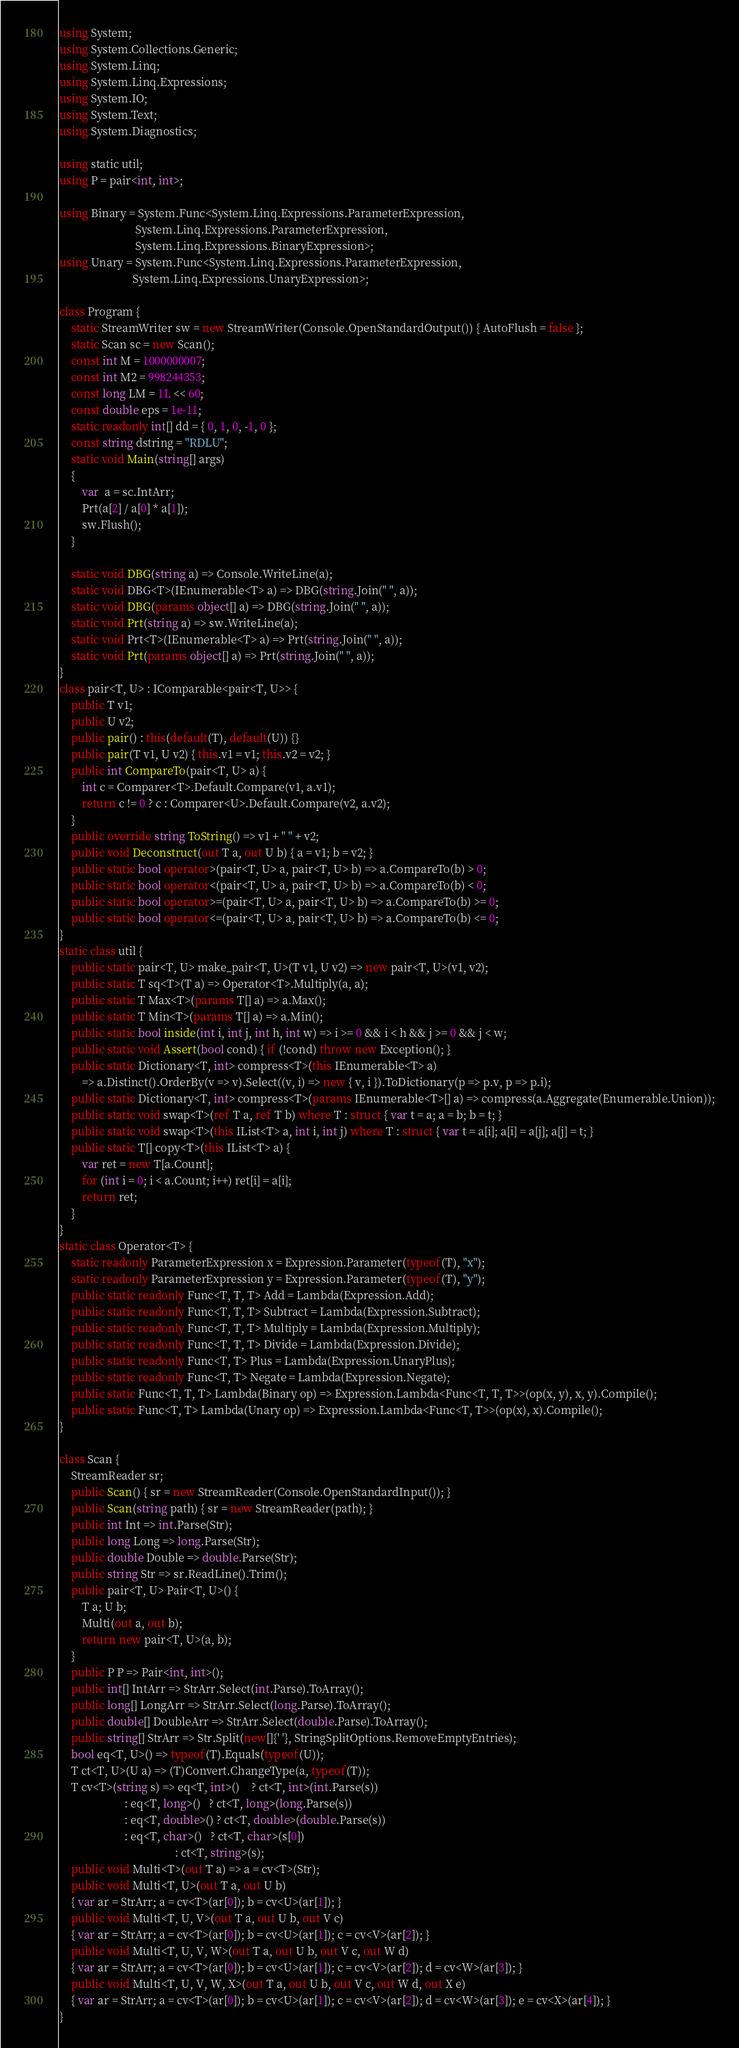<code> <loc_0><loc_0><loc_500><loc_500><_C#_>using System;
using System.Collections.Generic;
using System.Linq;
using System.Linq.Expressions;
using System.IO;
using System.Text;
using System.Diagnostics;

using static util;
using P = pair<int, int>;

using Binary = System.Func<System.Linq.Expressions.ParameterExpression,
                           System.Linq.Expressions.ParameterExpression,
                           System.Linq.Expressions.BinaryExpression>;
using Unary = System.Func<System.Linq.Expressions.ParameterExpression,
                          System.Linq.Expressions.UnaryExpression>;

class Program {
    static StreamWriter sw = new StreamWriter(Console.OpenStandardOutput()) { AutoFlush = false };
    static Scan sc = new Scan();
    const int M = 1000000007;
    const int M2 = 998244353;
    const long LM = 1L << 60;
    const double eps = 1e-11;
    static readonly int[] dd = { 0, 1, 0, -1, 0 };
    const string dstring = "RDLU";
    static void Main(string[] args)
    {
        var  a = sc.IntArr;
        Prt(a[2] / a[0] * a[1]);
        sw.Flush();
    }

    static void DBG(string a) => Console.WriteLine(a);
    static void DBG<T>(IEnumerable<T> a) => DBG(string.Join(" ", a));
    static void DBG(params object[] a) => DBG(string.Join(" ", a));
    static void Prt(string a) => sw.WriteLine(a);
    static void Prt<T>(IEnumerable<T> a) => Prt(string.Join(" ", a));
    static void Prt(params object[] a) => Prt(string.Join(" ", a));
}
class pair<T, U> : IComparable<pair<T, U>> {
    public T v1;
    public U v2;
    public pair() : this(default(T), default(U)) {}
    public pair(T v1, U v2) { this.v1 = v1; this.v2 = v2; }
    public int CompareTo(pair<T, U> a) {
        int c = Comparer<T>.Default.Compare(v1, a.v1);
        return c != 0 ? c : Comparer<U>.Default.Compare(v2, a.v2);
    }
    public override string ToString() => v1 + " " + v2;
    public void Deconstruct(out T a, out U b) { a = v1; b = v2; }
    public static bool operator>(pair<T, U> a, pair<T, U> b) => a.CompareTo(b) > 0;
    public static bool operator<(pair<T, U> a, pair<T, U> b) => a.CompareTo(b) < 0;
    public static bool operator>=(pair<T, U> a, pair<T, U> b) => a.CompareTo(b) >= 0;
    public static bool operator<=(pair<T, U> a, pair<T, U> b) => a.CompareTo(b) <= 0;
}
static class util {
    public static pair<T, U> make_pair<T, U>(T v1, U v2) => new pair<T, U>(v1, v2);
    public static T sq<T>(T a) => Operator<T>.Multiply(a, a);
    public static T Max<T>(params T[] a) => a.Max();
    public static T Min<T>(params T[] a) => a.Min();
    public static bool inside(int i, int j, int h, int w) => i >= 0 && i < h && j >= 0 && j < w;
    public static void Assert(bool cond) { if (!cond) throw new Exception(); }
    public static Dictionary<T, int> compress<T>(this IEnumerable<T> a)
        => a.Distinct().OrderBy(v => v).Select((v, i) => new { v, i }).ToDictionary(p => p.v, p => p.i);
    public static Dictionary<T, int> compress<T>(params IEnumerable<T>[] a) => compress(a.Aggregate(Enumerable.Union));
    public static void swap<T>(ref T a, ref T b) where T : struct { var t = a; a = b; b = t; }
    public static void swap<T>(this IList<T> a, int i, int j) where T : struct { var t = a[i]; a[i] = a[j]; a[j] = t; }
    public static T[] copy<T>(this IList<T> a) {
        var ret = new T[a.Count];
        for (int i = 0; i < a.Count; i++) ret[i] = a[i];
        return ret;
    }
}
static class Operator<T> {
    static readonly ParameterExpression x = Expression.Parameter(typeof(T), "x");
    static readonly ParameterExpression y = Expression.Parameter(typeof(T), "y");
    public static readonly Func<T, T, T> Add = Lambda(Expression.Add);
    public static readonly Func<T, T, T> Subtract = Lambda(Expression.Subtract);
    public static readonly Func<T, T, T> Multiply = Lambda(Expression.Multiply);
    public static readonly Func<T, T, T> Divide = Lambda(Expression.Divide);
    public static readonly Func<T, T> Plus = Lambda(Expression.UnaryPlus);
    public static readonly Func<T, T> Negate = Lambda(Expression.Negate);
    public static Func<T, T, T> Lambda(Binary op) => Expression.Lambda<Func<T, T, T>>(op(x, y), x, y).Compile();
    public static Func<T, T> Lambda(Unary op) => Expression.Lambda<Func<T, T>>(op(x), x).Compile();
}

class Scan {
    StreamReader sr;
    public Scan() { sr = new StreamReader(Console.OpenStandardInput()); }
    public Scan(string path) { sr = new StreamReader(path); }
    public int Int => int.Parse(Str);
    public long Long => long.Parse(Str);
    public double Double => double.Parse(Str);
    public string Str => sr.ReadLine().Trim();
    public pair<T, U> Pair<T, U>() {
        T a; U b;
        Multi(out a, out b);
        return new pair<T, U>(a, b);
    }
    public P P => Pair<int, int>();
    public int[] IntArr => StrArr.Select(int.Parse).ToArray();
    public long[] LongArr => StrArr.Select(long.Parse).ToArray();
    public double[] DoubleArr => StrArr.Select(double.Parse).ToArray();
    public string[] StrArr => Str.Split(new[]{' '}, StringSplitOptions.RemoveEmptyEntries);
    bool eq<T, U>() => typeof(T).Equals(typeof(U));
    T ct<T, U>(U a) => (T)Convert.ChangeType(a, typeof(T));
    T cv<T>(string s) => eq<T, int>()    ? ct<T, int>(int.Parse(s))
                       : eq<T, long>()   ? ct<T, long>(long.Parse(s))
                       : eq<T, double>() ? ct<T, double>(double.Parse(s))
                       : eq<T, char>()   ? ct<T, char>(s[0])
                                         : ct<T, string>(s);
    public void Multi<T>(out T a) => a = cv<T>(Str);
    public void Multi<T, U>(out T a, out U b)
    { var ar = StrArr; a = cv<T>(ar[0]); b = cv<U>(ar[1]); }
    public void Multi<T, U, V>(out T a, out U b, out V c)
    { var ar = StrArr; a = cv<T>(ar[0]); b = cv<U>(ar[1]); c = cv<V>(ar[2]); }
    public void Multi<T, U, V, W>(out T a, out U b, out V c, out W d)
    { var ar = StrArr; a = cv<T>(ar[0]); b = cv<U>(ar[1]); c = cv<V>(ar[2]); d = cv<W>(ar[3]); }
    public void Multi<T, U, V, W, X>(out T a, out U b, out V c, out W d, out X e)
    { var ar = StrArr; a = cv<T>(ar[0]); b = cv<U>(ar[1]); c = cv<V>(ar[2]); d = cv<W>(ar[3]); e = cv<X>(ar[4]); }
}
</code> 